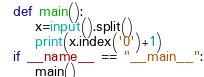<code> <loc_0><loc_0><loc_500><loc_500><_Python_>def main():
    x=input().split()
    print(x.index('0')+1)
if __name__ == "__main__":
    main()</code> 